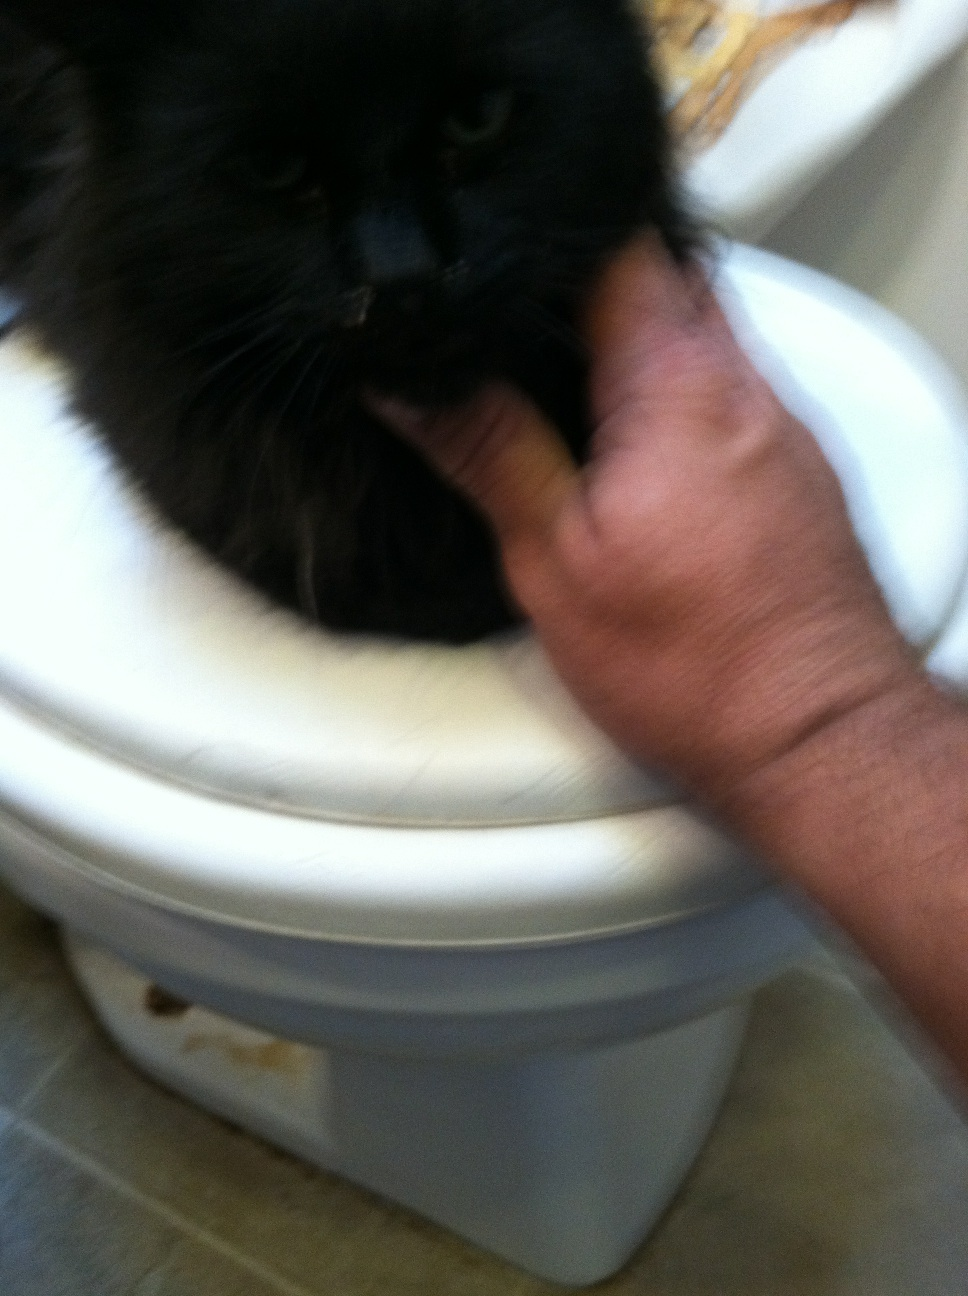Can you tell me what color this cat's eyes are? He's a stray. Unfortunately, due to the blurry nature of the photo, it is challenging to determine the color of the cat's eyes. To provide an accurate answer, a clearer image of the cat's face would be beneficial, particularly one where the eyes are in focus. If you have another opportunity to take a photo, try to ensure the cat's eyes are well-lit and the camera is steady to avoid blurriness. 